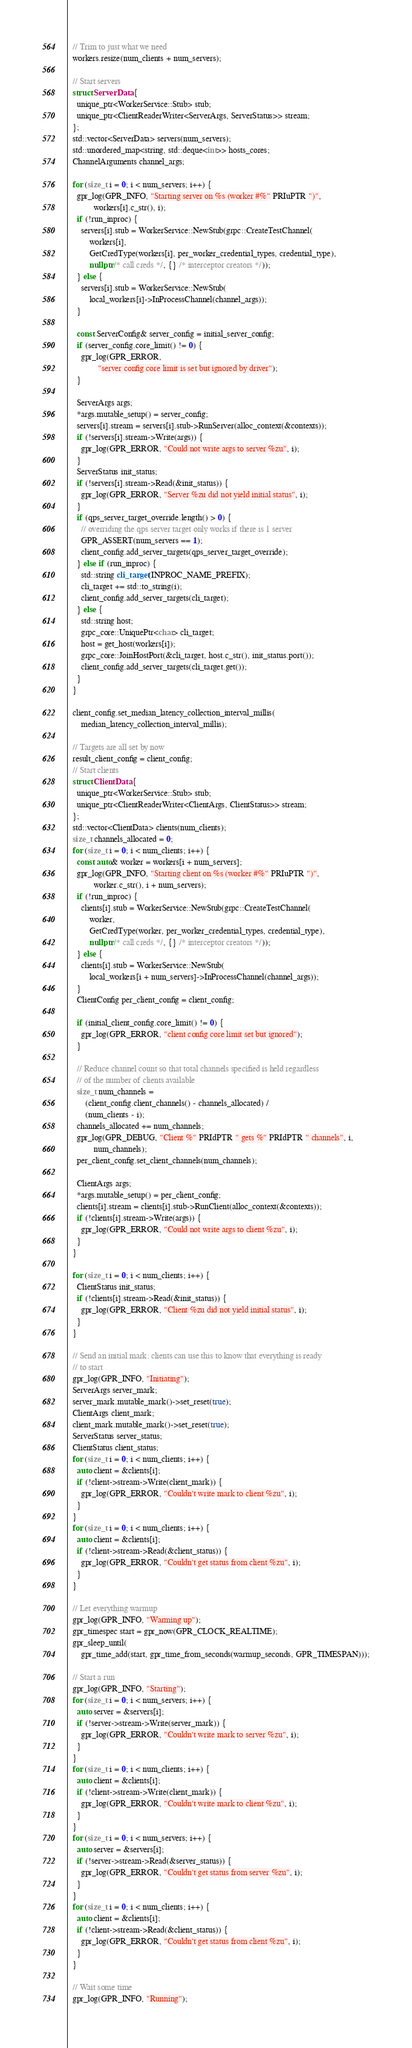Convert code to text. <code><loc_0><loc_0><loc_500><loc_500><_C++_>  // Trim to just what we need
  workers.resize(num_clients + num_servers);

  // Start servers
  struct ServerData {
    unique_ptr<WorkerService::Stub> stub;
    unique_ptr<ClientReaderWriter<ServerArgs, ServerStatus>> stream;
  };
  std::vector<ServerData> servers(num_servers);
  std::unordered_map<string, std::deque<int>> hosts_cores;
  ChannelArguments channel_args;

  for (size_t i = 0; i < num_servers; i++) {
    gpr_log(GPR_INFO, "Starting server on %s (worker #%" PRIuPTR ")",
            workers[i].c_str(), i);
    if (!run_inproc) {
      servers[i].stub = WorkerService::NewStub(grpc::CreateTestChannel(
          workers[i],
          GetCredType(workers[i], per_worker_credential_types, credential_type),
          nullptr /* call creds */, {} /* interceptor creators */));
    } else {
      servers[i].stub = WorkerService::NewStub(
          local_workers[i]->InProcessChannel(channel_args));
    }

    const ServerConfig& server_config = initial_server_config;
    if (server_config.core_limit() != 0) {
      gpr_log(GPR_ERROR,
              "server config core limit is set but ignored by driver");
    }

    ServerArgs args;
    *args.mutable_setup() = server_config;
    servers[i].stream = servers[i].stub->RunServer(alloc_context(&contexts));
    if (!servers[i].stream->Write(args)) {
      gpr_log(GPR_ERROR, "Could not write args to server %zu", i);
    }
    ServerStatus init_status;
    if (!servers[i].stream->Read(&init_status)) {
      gpr_log(GPR_ERROR, "Server %zu did not yield initial status", i);
    }
    if (qps_server_target_override.length() > 0) {
      // overriding the qps server target only works if there is 1 server
      GPR_ASSERT(num_servers == 1);
      client_config.add_server_targets(qps_server_target_override);
    } else if (run_inproc) {
      std::string cli_target(INPROC_NAME_PREFIX);
      cli_target += std::to_string(i);
      client_config.add_server_targets(cli_target);
    } else {
      std::string host;
      grpc_core::UniquePtr<char> cli_target;
      host = get_host(workers[i]);
      grpc_core::JoinHostPort(&cli_target, host.c_str(), init_status.port());
      client_config.add_server_targets(cli_target.get());
    }
  }

  client_config.set_median_latency_collection_interval_millis(
      median_latency_collection_interval_millis);

  // Targets are all set by now
  result_client_config = client_config;
  // Start clients
  struct ClientData {
    unique_ptr<WorkerService::Stub> stub;
    unique_ptr<ClientReaderWriter<ClientArgs, ClientStatus>> stream;
  };
  std::vector<ClientData> clients(num_clients);
  size_t channels_allocated = 0;
  for (size_t i = 0; i < num_clients; i++) {
    const auto& worker = workers[i + num_servers];
    gpr_log(GPR_INFO, "Starting client on %s (worker #%" PRIuPTR ")",
            worker.c_str(), i + num_servers);
    if (!run_inproc) {
      clients[i].stub = WorkerService::NewStub(grpc::CreateTestChannel(
          worker,
          GetCredType(worker, per_worker_credential_types, credential_type),
          nullptr /* call creds */, {} /* interceptor creators */));
    } else {
      clients[i].stub = WorkerService::NewStub(
          local_workers[i + num_servers]->InProcessChannel(channel_args));
    }
    ClientConfig per_client_config = client_config;

    if (initial_client_config.core_limit() != 0) {
      gpr_log(GPR_ERROR, "client config core limit set but ignored");
    }

    // Reduce channel count so that total channels specified is held regardless
    // of the number of clients available
    size_t num_channels =
        (client_config.client_channels() - channels_allocated) /
        (num_clients - i);
    channels_allocated += num_channels;
    gpr_log(GPR_DEBUG, "Client %" PRIdPTR " gets %" PRIdPTR " channels", i,
            num_channels);
    per_client_config.set_client_channels(num_channels);

    ClientArgs args;
    *args.mutable_setup() = per_client_config;
    clients[i].stream = clients[i].stub->RunClient(alloc_context(&contexts));
    if (!clients[i].stream->Write(args)) {
      gpr_log(GPR_ERROR, "Could not write args to client %zu", i);
    }
  }

  for (size_t i = 0; i < num_clients; i++) {
    ClientStatus init_status;
    if (!clients[i].stream->Read(&init_status)) {
      gpr_log(GPR_ERROR, "Client %zu did not yield initial status", i);
    }
  }

  // Send an initial mark: clients can use this to know that everything is ready
  // to start
  gpr_log(GPR_INFO, "Initiating");
  ServerArgs server_mark;
  server_mark.mutable_mark()->set_reset(true);
  ClientArgs client_mark;
  client_mark.mutable_mark()->set_reset(true);
  ServerStatus server_status;
  ClientStatus client_status;
  for (size_t i = 0; i < num_clients; i++) {
    auto client = &clients[i];
    if (!client->stream->Write(client_mark)) {
      gpr_log(GPR_ERROR, "Couldn't write mark to client %zu", i);
    }
  }
  for (size_t i = 0; i < num_clients; i++) {
    auto client = &clients[i];
    if (!client->stream->Read(&client_status)) {
      gpr_log(GPR_ERROR, "Couldn't get status from client %zu", i);
    }
  }

  // Let everything warmup
  gpr_log(GPR_INFO, "Warming up");
  gpr_timespec start = gpr_now(GPR_CLOCK_REALTIME);
  gpr_sleep_until(
      gpr_time_add(start, gpr_time_from_seconds(warmup_seconds, GPR_TIMESPAN)));

  // Start a run
  gpr_log(GPR_INFO, "Starting");
  for (size_t i = 0; i < num_servers; i++) {
    auto server = &servers[i];
    if (!server->stream->Write(server_mark)) {
      gpr_log(GPR_ERROR, "Couldn't write mark to server %zu", i);
    }
  }
  for (size_t i = 0; i < num_clients; i++) {
    auto client = &clients[i];
    if (!client->stream->Write(client_mark)) {
      gpr_log(GPR_ERROR, "Couldn't write mark to client %zu", i);
    }
  }
  for (size_t i = 0; i < num_servers; i++) {
    auto server = &servers[i];
    if (!server->stream->Read(&server_status)) {
      gpr_log(GPR_ERROR, "Couldn't get status from server %zu", i);
    }
  }
  for (size_t i = 0; i < num_clients; i++) {
    auto client = &clients[i];
    if (!client->stream->Read(&client_status)) {
      gpr_log(GPR_ERROR, "Couldn't get status from client %zu", i);
    }
  }

  // Wait some time
  gpr_log(GPR_INFO, "Running");</code> 